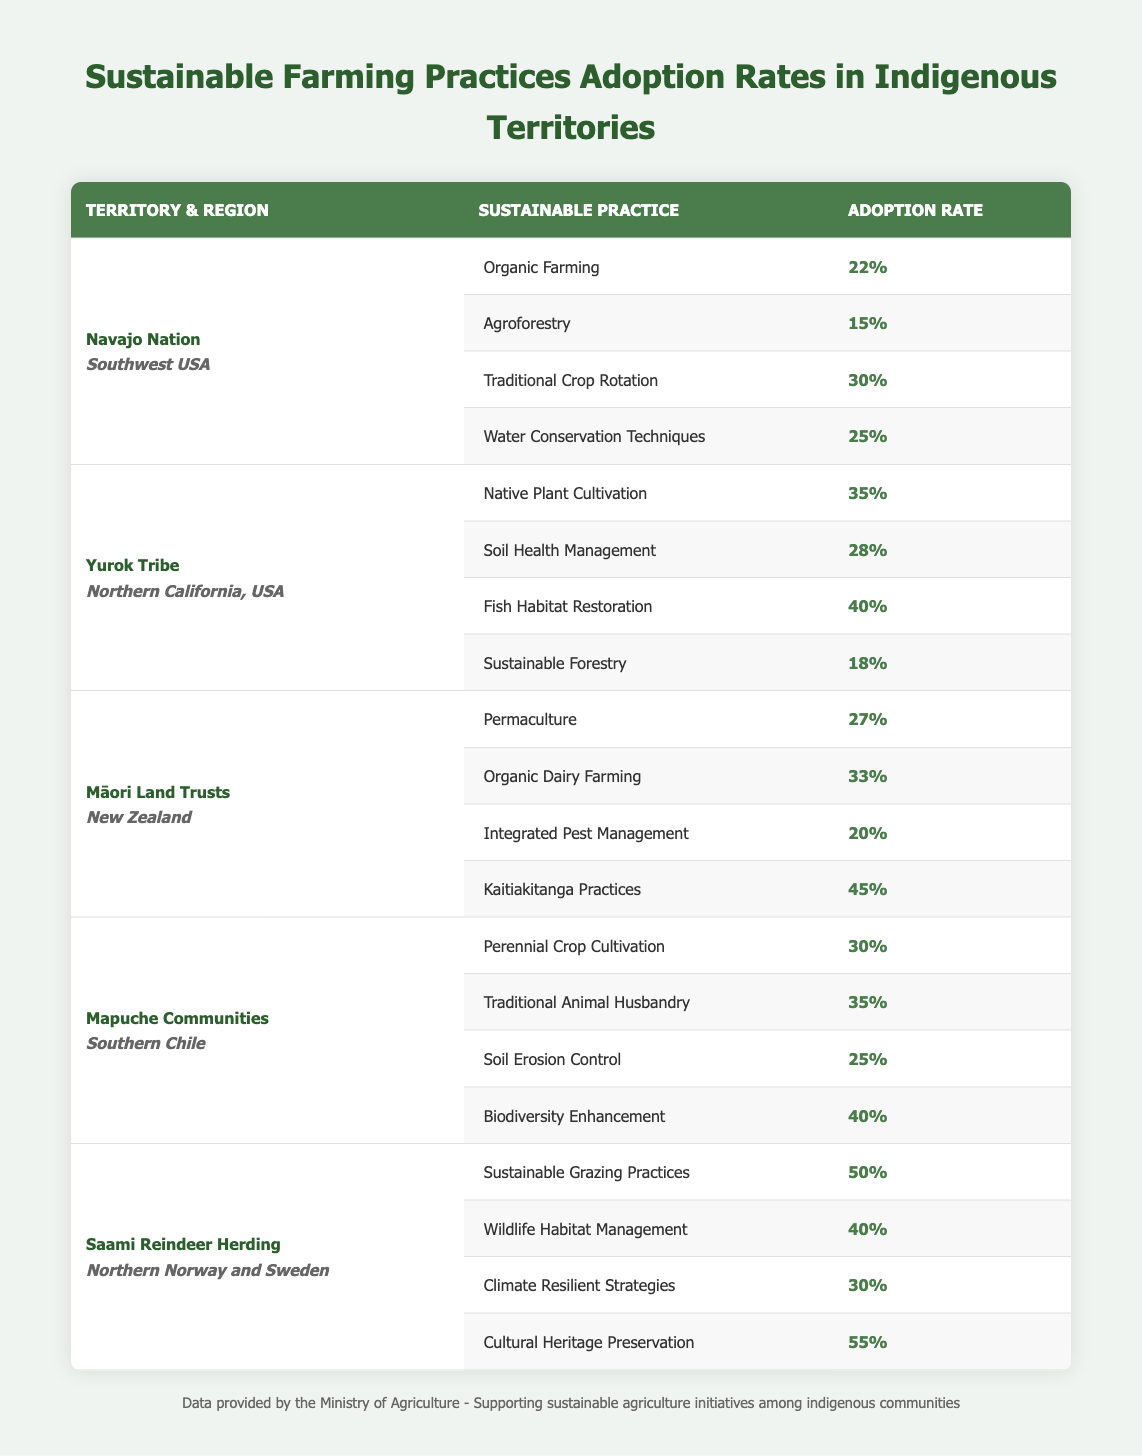What is the adoption rate for Sustainable Grazing Practices in Saami Reindeer Herding? According to the table under Saami Reindeer Herding, the Sustainable Grazing Practices have an adoption rate of 50%.
Answer: 50% Which territory has the highest adoption rate for Kaitiakitanga Practices? Looking at the table, Kaitiakitanga Practices have the highest adoption rate in Māori Land Trusts with a rate of 45%.
Answer: Māori Land Trusts If we consider all practices under the Yurok Tribe, what is the average adoption rate? The adoption rates for the Yurok Tribe are 35%, 28%, 40%, and 18%. Summing these up gives 35 + 28 + 40 + 18 = 121. Dividing this by the 4 practices gives us an average of 121/4 = 30.25%.
Answer: 30.25% Is the Traditional Crop Rotation adoption rate in Navajo Nation higher than 25%? In the table, the adoption rate for Traditional Crop Rotation in Navajo Nation is 30%, which is indeed higher than 25%.
Answer: Yes What is the difference in adoption rates between Organic Dairy Farming in Māori Land Trusts and Traditional Animal Husbandry in Mapuche Communities? From the table, Organic Dairy Farming has an adoption rate of 33% in Māori Land Trusts, and Traditional Animal Husbandry has a rate of 35% in Mapuche Communities. The difference is calculated as 35% - 33% = 2%.
Answer: 2% 